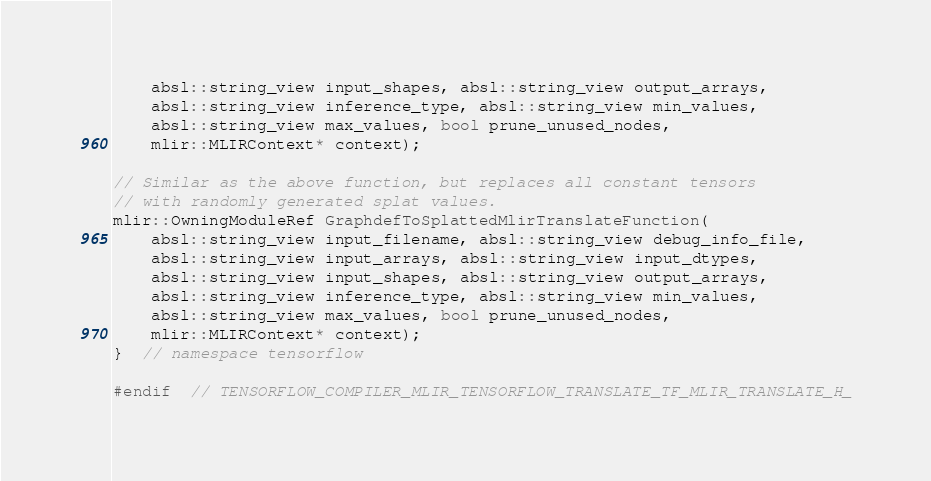<code> <loc_0><loc_0><loc_500><loc_500><_C_>    absl::string_view input_shapes, absl::string_view output_arrays,
    absl::string_view inference_type, absl::string_view min_values,
    absl::string_view max_values, bool prune_unused_nodes,
    mlir::MLIRContext* context);

// Similar as the above function, but replaces all constant tensors
// with randomly generated splat values.
mlir::OwningModuleRef GraphdefToSplattedMlirTranslateFunction(
    absl::string_view input_filename, absl::string_view debug_info_file,
    absl::string_view input_arrays, absl::string_view input_dtypes,
    absl::string_view input_shapes, absl::string_view output_arrays,
    absl::string_view inference_type, absl::string_view min_values,
    absl::string_view max_values, bool prune_unused_nodes,
    mlir::MLIRContext* context);
}  // namespace tensorflow

#endif  // TENSORFLOW_COMPILER_MLIR_TENSORFLOW_TRANSLATE_TF_MLIR_TRANSLATE_H_
</code> 